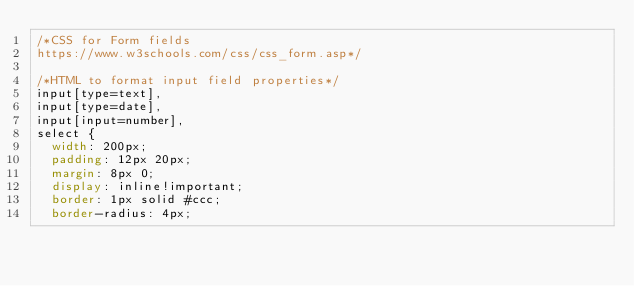Convert code to text. <code><loc_0><loc_0><loc_500><loc_500><_CSS_>/*CSS for Form fields
https://www.w3schools.com/css/css_form.asp*/

/*HTML to format input field properties*/
input[type=text],
input[type=date],
input[input=number],
select {
  width: 200px;
  padding: 12px 20px;
  margin: 8px 0;
  display: inline!important;
  border: 1px solid #ccc;
  border-radius: 4px;</code> 